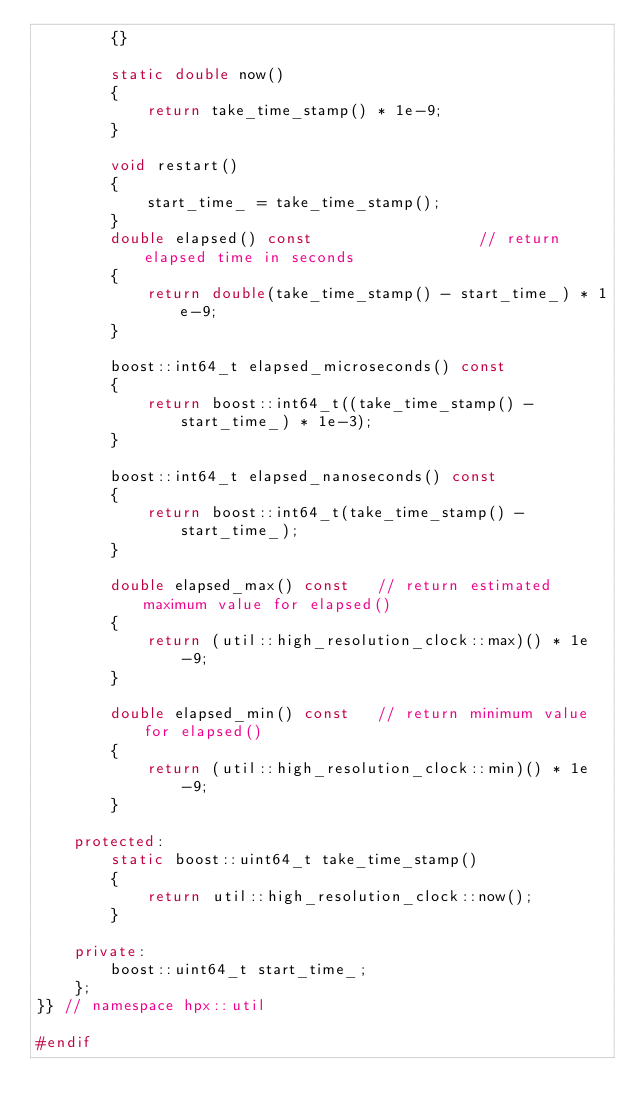<code> <loc_0><loc_0><loc_500><loc_500><_C++_>        {}

        static double now()
        {
            return take_time_stamp() * 1e-9;
        }

        void restart()
        {
            start_time_ = take_time_stamp();
        }
        double elapsed() const                  // return elapsed time in seconds
        {
            return double(take_time_stamp() - start_time_) * 1e-9;
        }

        boost::int64_t elapsed_microseconds() const
        {
            return boost::int64_t((take_time_stamp() - start_time_) * 1e-3);
        }

        boost::int64_t elapsed_nanoseconds() const
        {
            return boost::int64_t(take_time_stamp() - start_time_);
        }

        double elapsed_max() const   // return estimated maximum value for elapsed()
        {
            return (util::high_resolution_clock::max)() * 1e-9;
        }

        double elapsed_min() const   // return minimum value for elapsed()
        {
            return (util::high_resolution_clock::min)() * 1e-9;
        }

    protected:
        static boost::uint64_t take_time_stamp()
        {
            return util::high_resolution_clock::now();
        }

    private:
        boost::uint64_t start_time_;
    };
}} // namespace hpx::util

#endif

</code> 